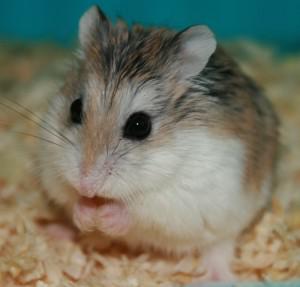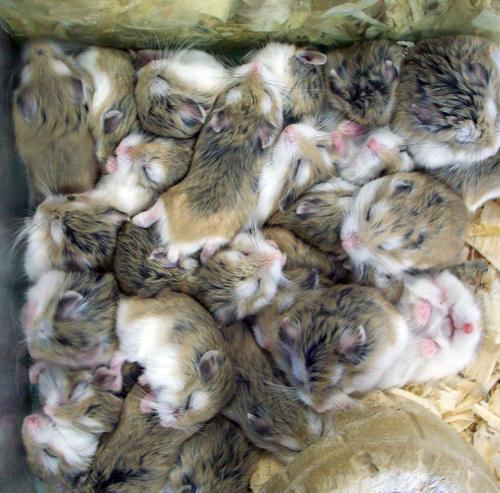The first image is the image on the left, the second image is the image on the right. Examine the images to the left and right. Is the description "An image shows one adult rodent with more than one newborn nearby." accurate? Answer yes or no. No. The first image is the image on the left, the second image is the image on the right. Given the left and right images, does the statement "There are at least two newborn rodents." hold true? Answer yes or no. No. 